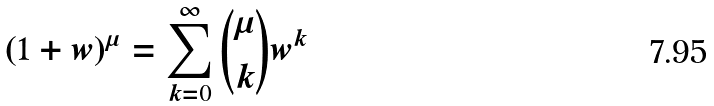Convert formula to latex. <formula><loc_0><loc_0><loc_500><loc_500>( 1 + w ) ^ { \mu } = \sum _ { k = 0 } ^ { \infty } \binom { \mu } { k } w ^ { k }</formula> 